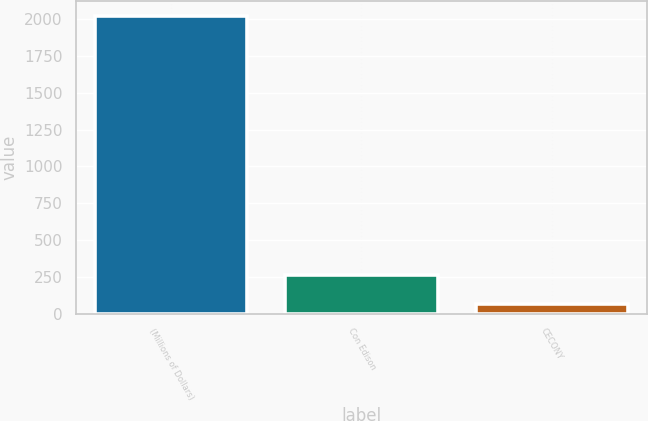Convert chart to OTSL. <chart><loc_0><loc_0><loc_500><loc_500><bar_chart><fcel>(Millions of Dollars)<fcel>Con Edison<fcel>CECONY<nl><fcel>2020<fcel>262.3<fcel>67<nl></chart> 